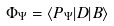<formula> <loc_0><loc_0><loc_500><loc_500>\Phi _ { \Psi } = \langle P _ { \Psi } | D | B \rangle</formula> 